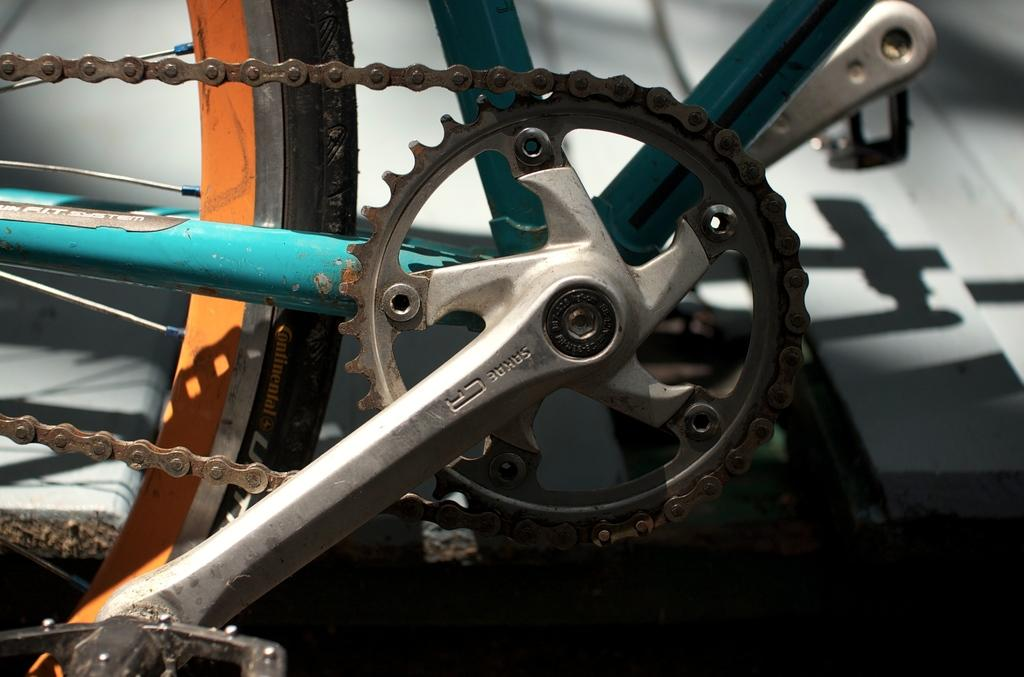What is the main object in the image? There is a bicycle in the image. What are some of the components of the bicycle that can be seen? There is a Tyre, a chain, and pedals visible in the image. How many dolls are sitting on the cup in the image? There are no dolls or cups present in the image; it features a bicycle with a Tyre, chain, and pedals. 